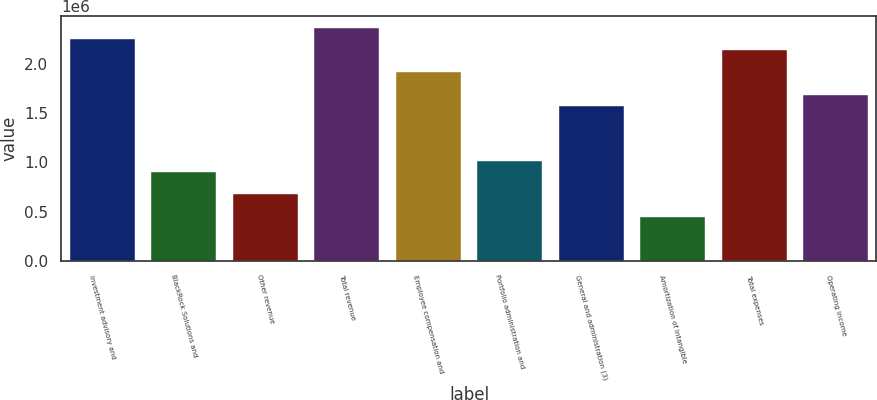<chart> <loc_0><loc_0><loc_500><loc_500><bar_chart><fcel>Investment advisory and<fcel>BlackRock Solutions and<fcel>Other revenue<fcel>Total revenue<fcel>Employee compensation and<fcel>Portfolio administration and<fcel>General and administration (3)<fcel>Amortization of intangible<fcel>Total expenses<fcel>Operating income<nl><fcel>2.24925e+06<fcel>899702<fcel>674777<fcel>2.36171e+06<fcel>1.91186e+06<fcel>1.01216e+06<fcel>1.57448e+06<fcel>449852<fcel>2.13679e+06<fcel>1.68694e+06<nl></chart> 